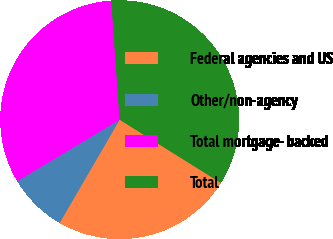<chart> <loc_0><loc_0><loc_500><loc_500><pie_chart><fcel>Federal agencies and US<fcel>Other/non-agency<fcel>Total mortgage- backed<fcel>Total<nl><fcel>24.49%<fcel>8.01%<fcel>32.5%<fcel>35.0%<nl></chart> 